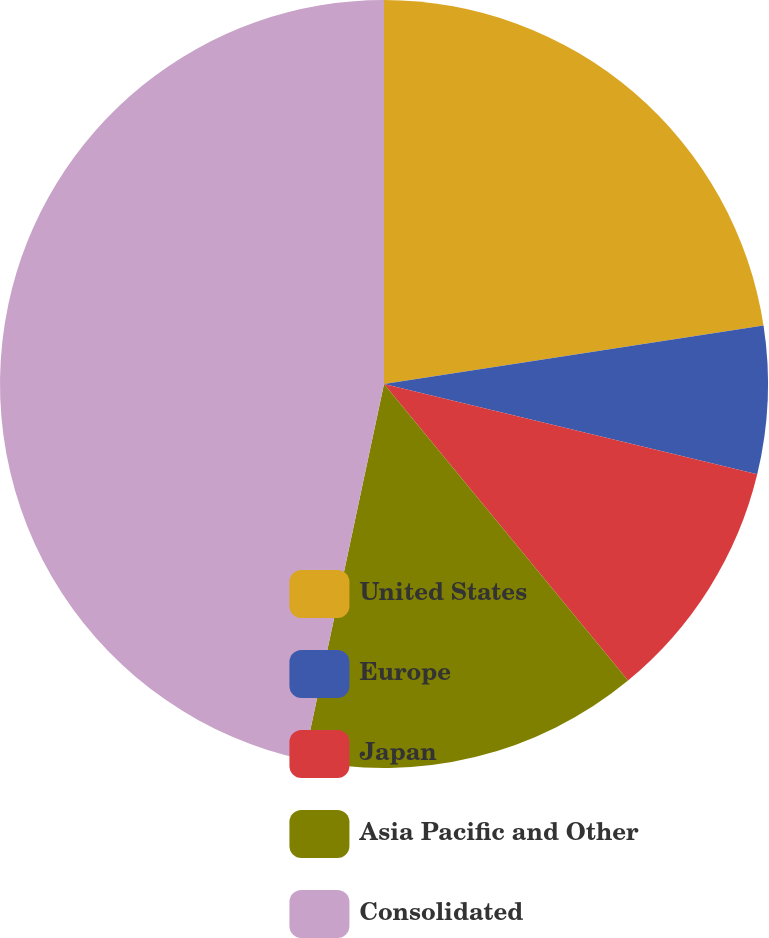Convert chart to OTSL. <chart><loc_0><loc_0><loc_500><loc_500><pie_chart><fcel>United States<fcel>Europe<fcel>Japan<fcel>Asia Pacific and Other<fcel>Consolidated<nl><fcel>22.57%<fcel>6.21%<fcel>10.26%<fcel>14.3%<fcel>46.66%<nl></chart> 